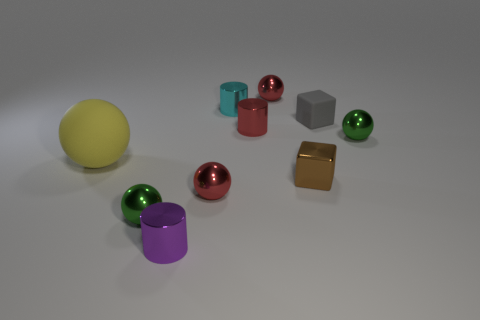Subtract all large yellow balls. How many balls are left? 4 Subtract all red cylinders. How many cylinders are left? 2 Subtract 2 balls. How many balls are left? 3 Subtract all yellow spheres. How many gray blocks are left? 1 Add 8 tiny matte cubes. How many tiny matte cubes exist? 9 Subtract 1 red cylinders. How many objects are left? 9 Subtract all cubes. How many objects are left? 8 Subtract all gray blocks. Subtract all red cylinders. How many blocks are left? 1 Subtract all cyan metallic cylinders. Subtract all small cyan cylinders. How many objects are left? 8 Add 4 tiny green objects. How many tiny green objects are left? 6 